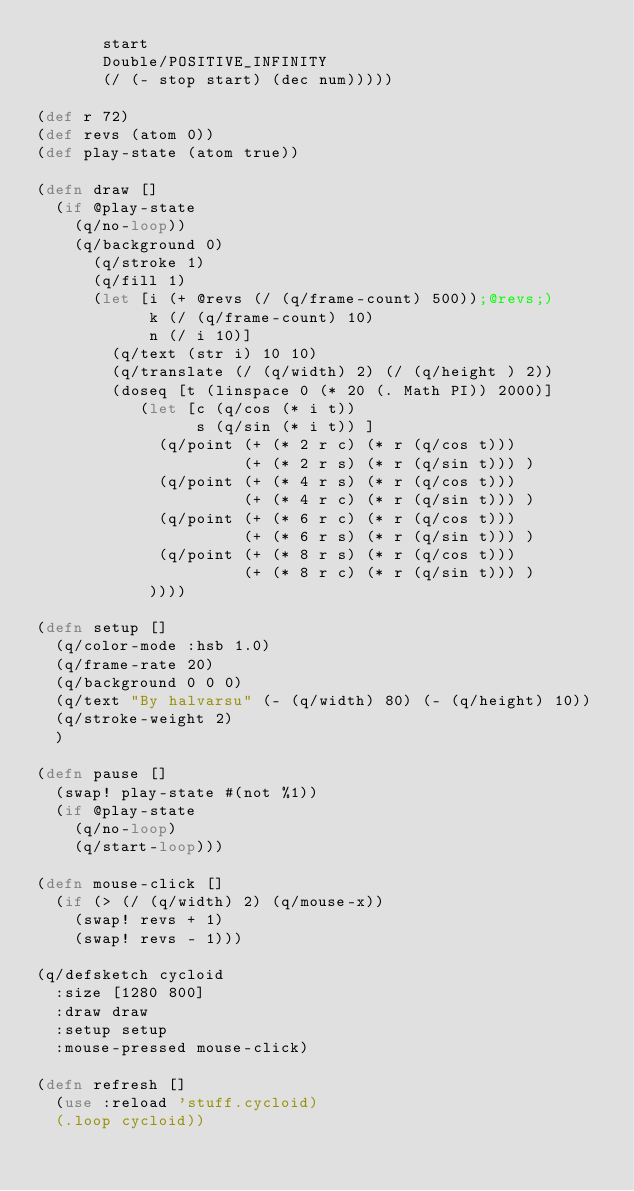Convert code to text. <code><loc_0><loc_0><loc_500><loc_500><_Clojure_>       start
       Double/POSITIVE_INFINITY
       (/ (- stop start) (dec num)))))

(def r 72)
(def revs (atom 0))
(def play-state (atom true))

(defn draw []
  (if @play-state
    (q/no-loop))
    (q/background 0)
      (q/stroke 1)
      (q/fill 1)
      (let [i (+ @revs (/ (q/frame-count) 500));@revs;)
            k (/ (q/frame-count) 10)
            n (/ i 10)]
        (q/text (str i) 10 10)
        (q/translate (/ (q/width) 2) (/ (q/height ) 2))
        (doseq [t (linspace 0 (* 20 (. Math PI)) 2000)]
           (let [c (q/cos (* i t))
                 s (q/sin (* i t)) ]
             (q/point (+ (* 2 r c) (* r (q/cos t))) 
                      (+ (* 2 r s) (* r (q/sin t))) )
             (q/point (+ (* 4 r s) (* r (q/cos t))) 
                      (+ (* 4 r c) (* r (q/sin t))) )
             (q/point (+ (* 6 r c) (* r (q/cos t))) 
                      (+ (* 6 r s) (* r (q/sin t))) )
             (q/point (+ (* 8 r s) (* r (q/cos t))) 
                      (+ (* 8 r c) (* r (q/sin t))) )
            ))))

(defn setup []
  (q/color-mode :hsb 1.0)
  (q/frame-rate 20)
  (q/background 0 0 0)
  (q/text "By halvarsu" (- (q/width) 80) (- (q/height) 10))
  (q/stroke-weight 2)
  )

(defn pause []
  (swap! play-state #(not %1))
  (if @play-state
    (q/no-loop)
    (q/start-loop)))

(defn mouse-click []
  (if (> (/ (q/width) 2) (q/mouse-x))
    (swap! revs + 1)
    (swap! revs - 1)))

(q/defsketch cycloid
  :size [1280 800]
  :draw draw
  :setup setup
  :mouse-pressed mouse-click)

(defn refresh []
  (use :reload 'stuff.cycloid)
  (.loop cycloid))
</code> 